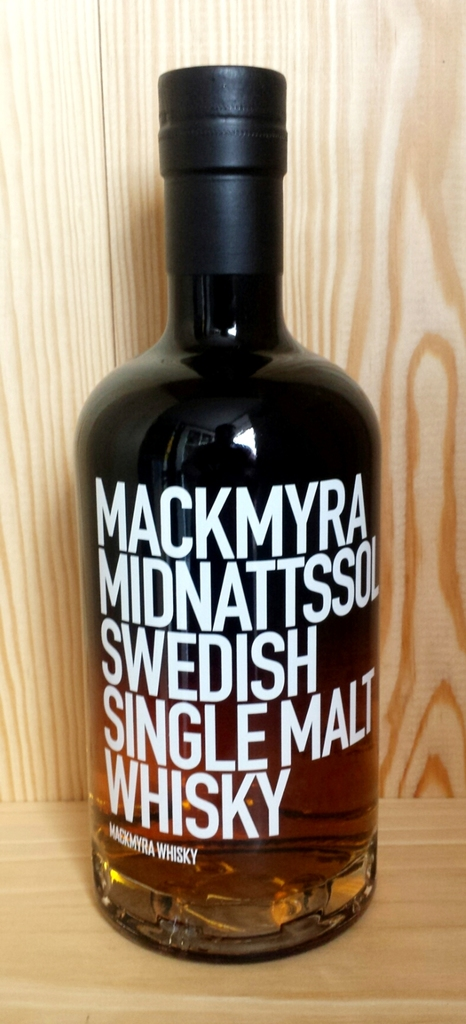Can you elaborate on the elements of the picture provided? The image prominently features a bottle of Mackmyra Midnattssol, a notable Swedish Single Malt Whisky. The sleek, black bottle provides a stark contrast to the visually striking white label, which bears the name of the whisky and its origin in bold, clear text. The whisky itself has a rich amber hue, visible at the base of the bottle, suggesting its aged quality. Positioned against a backdrop of light wood grain that may hint at the barrels used for aging this fine spirit, the overall presentation is both elegant and inviting, reflecting the premium nature of the product. 